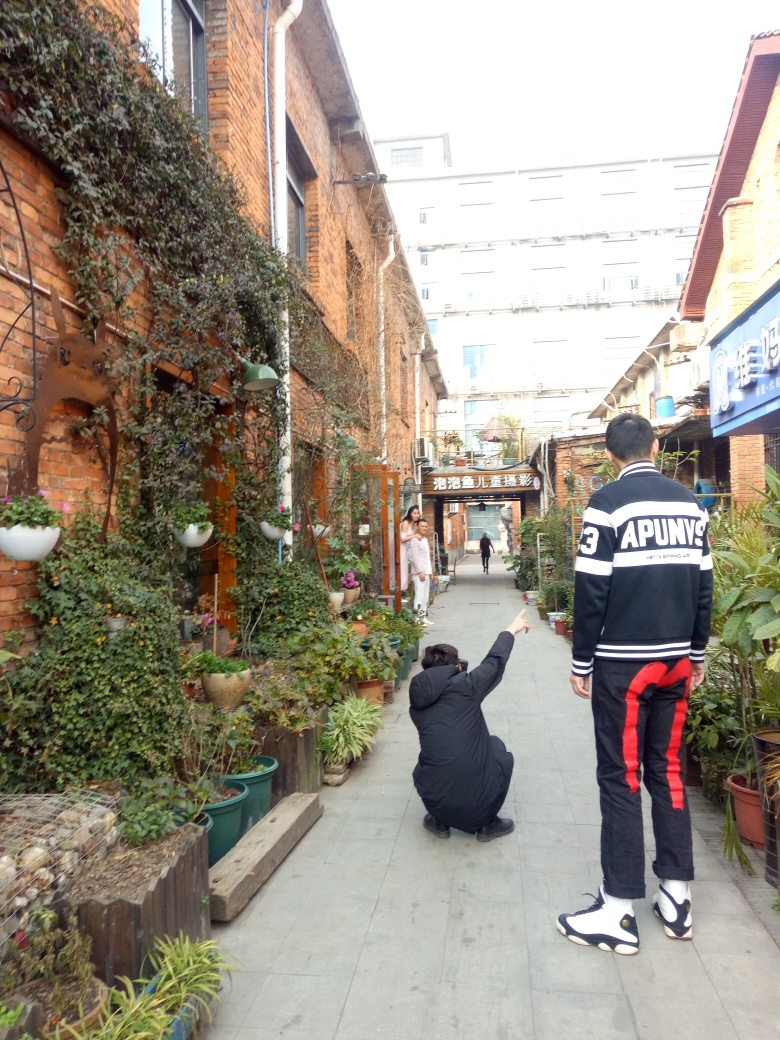What is the overall clarity of this image?
A. Poor
B. Excellent
C. Acceptable
Answer with the option's letter from the given choices directly.
 C. 